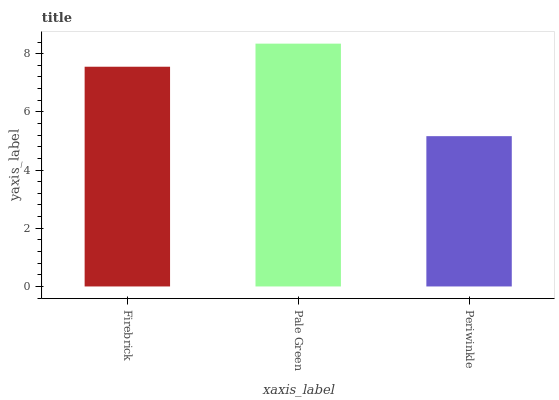Is Periwinkle the minimum?
Answer yes or no. Yes. Is Pale Green the maximum?
Answer yes or no. Yes. Is Pale Green the minimum?
Answer yes or no. No. Is Periwinkle the maximum?
Answer yes or no. No. Is Pale Green greater than Periwinkle?
Answer yes or no. Yes. Is Periwinkle less than Pale Green?
Answer yes or no. Yes. Is Periwinkle greater than Pale Green?
Answer yes or no. No. Is Pale Green less than Periwinkle?
Answer yes or no. No. Is Firebrick the high median?
Answer yes or no. Yes. Is Firebrick the low median?
Answer yes or no. Yes. Is Pale Green the high median?
Answer yes or no. No. Is Pale Green the low median?
Answer yes or no. No. 